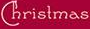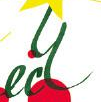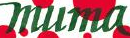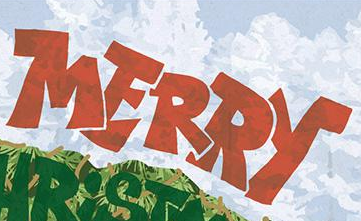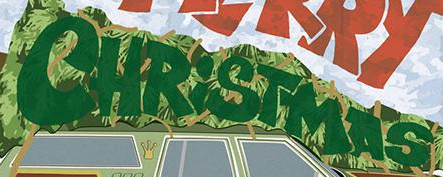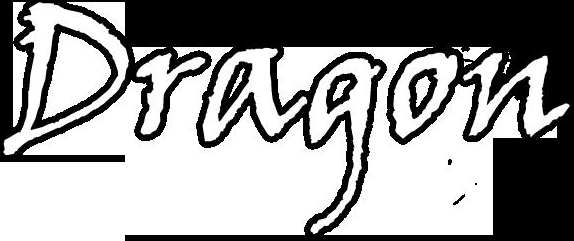What words can you see in these images in sequence, separated by a semicolon? Christmas; ecy; muma; MERRY; CHRiSTMAS; Dragon 